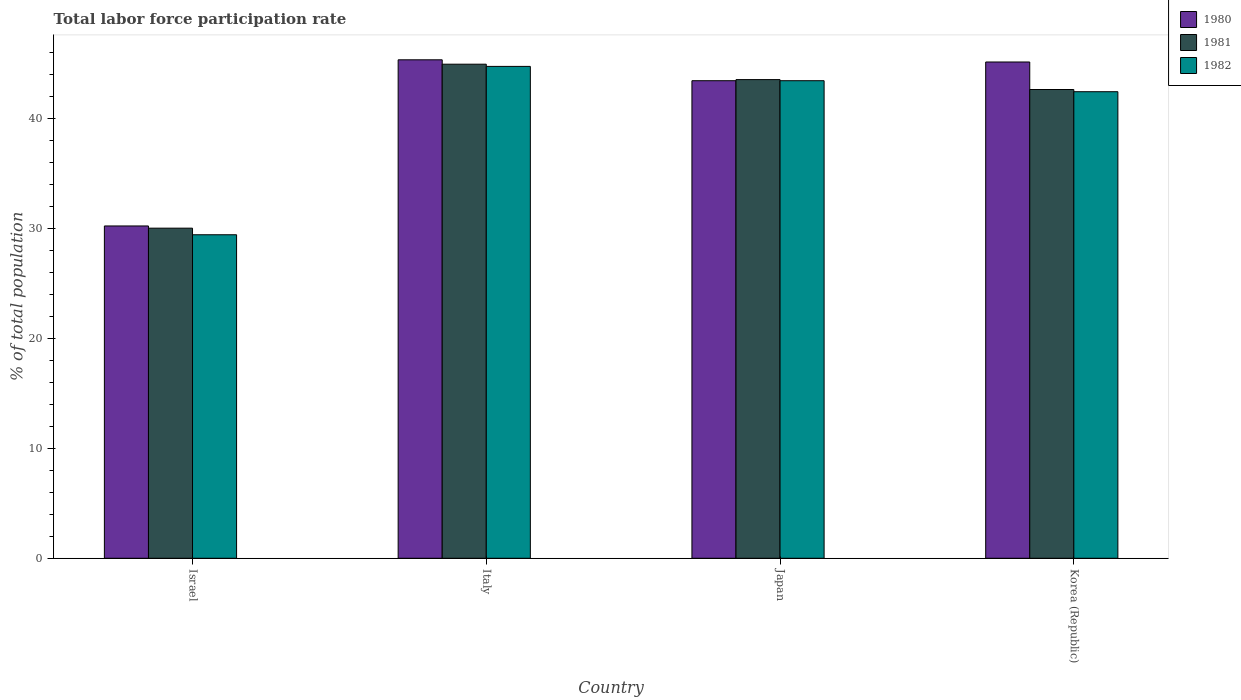How many different coloured bars are there?
Your answer should be very brief. 3. Are the number of bars per tick equal to the number of legend labels?
Keep it short and to the point. Yes. How many bars are there on the 2nd tick from the left?
Give a very brief answer. 3. How many bars are there on the 4th tick from the right?
Provide a succinct answer. 3. What is the label of the 4th group of bars from the left?
Your response must be concise. Korea (Republic). What is the total labor force participation rate in 1981 in Japan?
Offer a terse response. 43.5. Across all countries, what is the maximum total labor force participation rate in 1980?
Provide a succinct answer. 45.3. Across all countries, what is the minimum total labor force participation rate in 1982?
Provide a succinct answer. 29.4. In which country was the total labor force participation rate in 1982 maximum?
Keep it short and to the point. Italy. In which country was the total labor force participation rate in 1980 minimum?
Your answer should be compact. Israel. What is the total total labor force participation rate in 1981 in the graph?
Ensure brevity in your answer.  161. What is the difference between the total labor force participation rate in 1982 in Israel and that in Japan?
Make the answer very short. -14. What is the difference between the total labor force participation rate in 1982 in Israel and the total labor force participation rate in 1981 in Japan?
Make the answer very short. -14.1. What is the difference between the total labor force participation rate of/in 1982 and total labor force participation rate of/in 1980 in Italy?
Give a very brief answer. -0.6. What is the ratio of the total labor force participation rate in 1980 in Israel to that in Italy?
Ensure brevity in your answer.  0.67. Is the total labor force participation rate in 1981 in Italy less than that in Japan?
Your response must be concise. No. Is the difference between the total labor force participation rate in 1982 in Israel and Korea (Republic) greater than the difference between the total labor force participation rate in 1980 in Israel and Korea (Republic)?
Ensure brevity in your answer.  Yes. What is the difference between the highest and the second highest total labor force participation rate in 1980?
Your answer should be very brief. -1.7. What is the difference between the highest and the lowest total labor force participation rate in 1981?
Ensure brevity in your answer.  14.9. Is the sum of the total labor force participation rate in 1982 in Japan and Korea (Republic) greater than the maximum total labor force participation rate in 1981 across all countries?
Give a very brief answer. Yes. Are all the bars in the graph horizontal?
Ensure brevity in your answer.  No. What is the difference between two consecutive major ticks on the Y-axis?
Your answer should be very brief. 10. Are the values on the major ticks of Y-axis written in scientific E-notation?
Give a very brief answer. No. Does the graph contain grids?
Your response must be concise. No. How many legend labels are there?
Your response must be concise. 3. How are the legend labels stacked?
Give a very brief answer. Vertical. What is the title of the graph?
Your answer should be compact. Total labor force participation rate. Does "1977" appear as one of the legend labels in the graph?
Provide a short and direct response. No. What is the label or title of the X-axis?
Keep it short and to the point. Country. What is the label or title of the Y-axis?
Your answer should be compact. % of total population. What is the % of total population of 1980 in Israel?
Your answer should be very brief. 30.2. What is the % of total population of 1981 in Israel?
Your response must be concise. 30. What is the % of total population of 1982 in Israel?
Your answer should be very brief. 29.4. What is the % of total population in 1980 in Italy?
Your response must be concise. 45.3. What is the % of total population in 1981 in Italy?
Offer a very short reply. 44.9. What is the % of total population in 1982 in Italy?
Your response must be concise. 44.7. What is the % of total population in 1980 in Japan?
Provide a succinct answer. 43.4. What is the % of total population in 1981 in Japan?
Your response must be concise. 43.5. What is the % of total population in 1982 in Japan?
Provide a short and direct response. 43.4. What is the % of total population in 1980 in Korea (Republic)?
Keep it short and to the point. 45.1. What is the % of total population of 1981 in Korea (Republic)?
Keep it short and to the point. 42.6. What is the % of total population in 1982 in Korea (Republic)?
Offer a very short reply. 42.4. Across all countries, what is the maximum % of total population in 1980?
Your answer should be compact. 45.3. Across all countries, what is the maximum % of total population in 1981?
Make the answer very short. 44.9. Across all countries, what is the maximum % of total population of 1982?
Ensure brevity in your answer.  44.7. Across all countries, what is the minimum % of total population in 1980?
Make the answer very short. 30.2. Across all countries, what is the minimum % of total population of 1982?
Offer a terse response. 29.4. What is the total % of total population in 1980 in the graph?
Your answer should be compact. 164. What is the total % of total population in 1981 in the graph?
Provide a short and direct response. 161. What is the total % of total population in 1982 in the graph?
Your answer should be compact. 159.9. What is the difference between the % of total population of 1980 in Israel and that in Italy?
Offer a very short reply. -15.1. What is the difference between the % of total population in 1981 in Israel and that in Italy?
Make the answer very short. -14.9. What is the difference between the % of total population in 1982 in Israel and that in Italy?
Offer a terse response. -15.3. What is the difference between the % of total population in 1980 in Israel and that in Japan?
Your answer should be very brief. -13.2. What is the difference between the % of total population in 1981 in Israel and that in Japan?
Ensure brevity in your answer.  -13.5. What is the difference between the % of total population in 1980 in Israel and that in Korea (Republic)?
Your answer should be compact. -14.9. What is the difference between the % of total population of 1982 in Israel and that in Korea (Republic)?
Ensure brevity in your answer.  -13. What is the difference between the % of total population in 1980 in Italy and that in Japan?
Your answer should be very brief. 1.9. What is the difference between the % of total population in 1980 in Japan and that in Korea (Republic)?
Make the answer very short. -1.7. What is the difference between the % of total population of 1981 in Japan and that in Korea (Republic)?
Offer a very short reply. 0.9. What is the difference between the % of total population of 1982 in Japan and that in Korea (Republic)?
Offer a terse response. 1. What is the difference between the % of total population of 1980 in Israel and the % of total population of 1981 in Italy?
Provide a short and direct response. -14.7. What is the difference between the % of total population in 1981 in Israel and the % of total population in 1982 in Italy?
Offer a very short reply. -14.7. What is the difference between the % of total population of 1980 in Israel and the % of total population of 1982 in Japan?
Make the answer very short. -13.2. What is the difference between the % of total population in 1981 in Israel and the % of total population in 1982 in Korea (Republic)?
Offer a very short reply. -12.4. What is the difference between the % of total population of 1980 in Italy and the % of total population of 1981 in Japan?
Offer a terse response. 1.8. What is the difference between the % of total population in 1980 in Italy and the % of total population in 1982 in Japan?
Ensure brevity in your answer.  1.9. What is the difference between the % of total population in 1980 in Italy and the % of total population in 1981 in Korea (Republic)?
Make the answer very short. 2.7. What is the difference between the % of total population in 1980 in Japan and the % of total population in 1981 in Korea (Republic)?
Offer a very short reply. 0.8. What is the difference between the % of total population of 1980 in Japan and the % of total population of 1982 in Korea (Republic)?
Give a very brief answer. 1. What is the average % of total population of 1981 per country?
Your response must be concise. 40.25. What is the average % of total population of 1982 per country?
Your response must be concise. 39.98. What is the difference between the % of total population in 1980 and % of total population in 1981 in Israel?
Keep it short and to the point. 0.2. What is the difference between the % of total population of 1980 and % of total population of 1981 in Italy?
Provide a short and direct response. 0.4. What is the difference between the % of total population of 1980 and % of total population of 1981 in Japan?
Provide a short and direct response. -0.1. What is the difference between the % of total population in 1980 and % of total population in 1981 in Korea (Republic)?
Ensure brevity in your answer.  2.5. What is the difference between the % of total population in 1980 and % of total population in 1982 in Korea (Republic)?
Keep it short and to the point. 2.7. What is the difference between the % of total population in 1981 and % of total population in 1982 in Korea (Republic)?
Make the answer very short. 0.2. What is the ratio of the % of total population in 1981 in Israel to that in Italy?
Keep it short and to the point. 0.67. What is the ratio of the % of total population of 1982 in Israel to that in Italy?
Provide a succinct answer. 0.66. What is the ratio of the % of total population of 1980 in Israel to that in Japan?
Provide a succinct answer. 0.7. What is the ratio of the % of total population in 1981 in Israel to that in Japan?
Offer a terse response. 0.69. What is the ratio of the % of total population in 1982 in Israel to that in Japan?
Ensure brevity in your answer.  0.68. What is the ratio of the % of total population in 1980 in Israel to that in Korea (Republic)?
Your response must be concise. 0.67. What is the ratio of the % of total population in 1981 in Israel to that in Korea (Republic)?
Provide a succinct answer. 0.7. What is the ratio of the % of total population in 1982 in Israel to that in Korea (Republic)?
Offer a very short reply. 0.69. What is the ratio of the % of total population in 1980 in Italy to that in Japan?
Keep it short and to the point. 1.04. What is the ratio of the % of total population of 1981 in Italy to that in Japan?
Keep it short and to the point. 1.03. What is the ratio of the % of total population in 1981 in Italy to that in Korea (Republic)?
Keep it short and to the point. 1.05. What is the ratio of the % of total population in 1982 in Italy to that in Korea (Republic)?
Offer a very short reply. 1.05. What is the ratio of the % of total population in 1980 in Japan to that in Korea (Republic)?
Provide a succinct answer. 0.96. What is the ratio of the % of total population of 1981 in Japan to that in Korea (Republic)?
Keep it short and to the point. 1.02. What is the ratio of the % of total population in 1982 in Japan to that in Korea (Republic)?
Provide a short and direct response. 1.02. What is the difference between the highest and the second highest % of total population of 1980?
Your answer should be very brief. 0.2. What is the difference between the highest and the lowest % of total population in 1980?
Offer a very short reply. 15.1. What is the difference between the highest and the lowest % of total population in 1982?
Offer a very short reply. 15.3. 